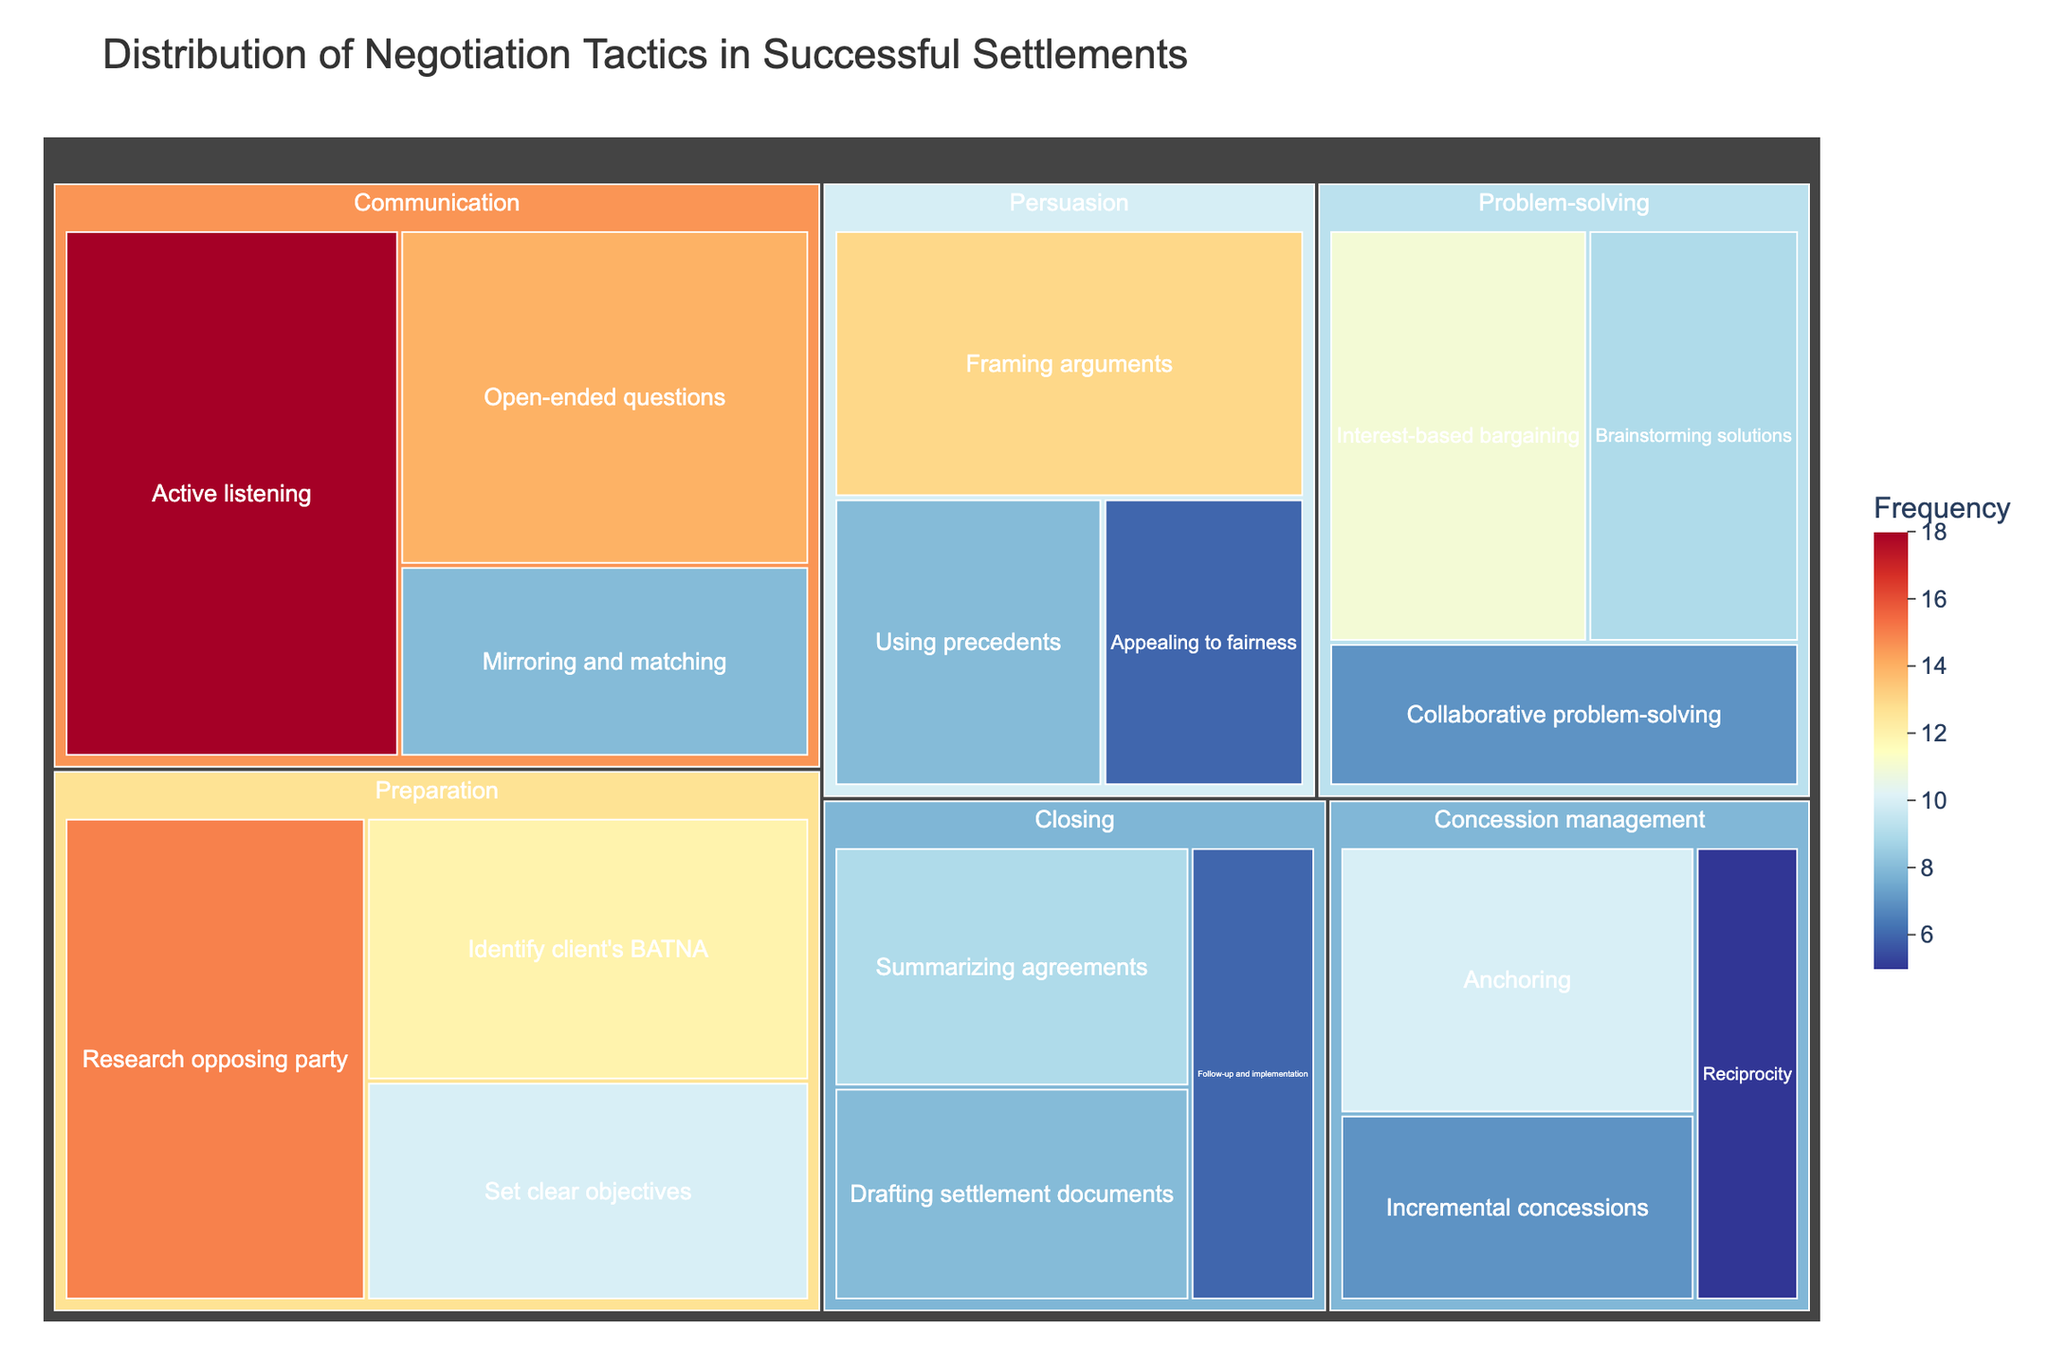What is the title of the figure? The title is usually located at the top of the figure and summarizes its content. The title of this treemap is "Distribution of Negotiation Tactics in Successful Settlements".
Answer: Distribution of Negotiation Tactics in Successful Settlements Which assessment category has the highest number of tactics combined? Sum the frequencies of all tactics within each category. Comparing totals, Preparation has 15+12+10=37, Communication has 18+8+14=40, Problem-solving has 9+11+7=27, Persuasion has 13+8+6=27, Concession management has 10+7+5=22, and Closing has 9+8+6=23. Communication is the highest with 40.
Answer: Communication Which tactic in the "Persuasion" category has the highest frequency? Look within the "Persuasion" category and compare the frequencies of each tactic. "Framing arguments" has 13, "Using precedents" has 8, and "Appealing to fairness" has 6. The highest is "Framing arguments" with 13.
Answer: Framing arguments What is the average frequency of tactics in the "Closing" category? Sum the frequencies in the "Closing" category and divide by the number of tactics. (9+8+6) / 3 = 23 / 3 ≈ 7.67.
Answer: 7.67 Which category contains the tactic with the highest frequency overall? Identify the tactics with the highest frequency from all categories. "Active listening" from Communication has the highest frequency of 18.
Answer: Communication What is the total frequency of all tactics related to 'Preparation'? Sum the frequencies of all tactics in the Preparation category: 15+12+10 = 37.
Answer: 37 How many tactics have a frequency of 10 or greater? Count the number of tactics where the frequency is 10 or higher: "Research opposing party" (15), "Identify client's BATNA" (12), "Set clear objectives" (10), "Active listening" (18), "Open-ended questions" (14), "Interest-based bargaining" (11), "Framing arguments" (13), "Anchoring" (10). There are 8 such tactics.
Answer: 8 Which is the least frequent problem-solving tactic? Compare the frequencies for problem-solving tactics: "Brainstorming solutions" (9), "Interest-based bargaining" (11), and "Collaborative problem-solving" (7). "Collaborative problem-solving" is the least frequent with 7.
Answer: Collaborative problem-solving 